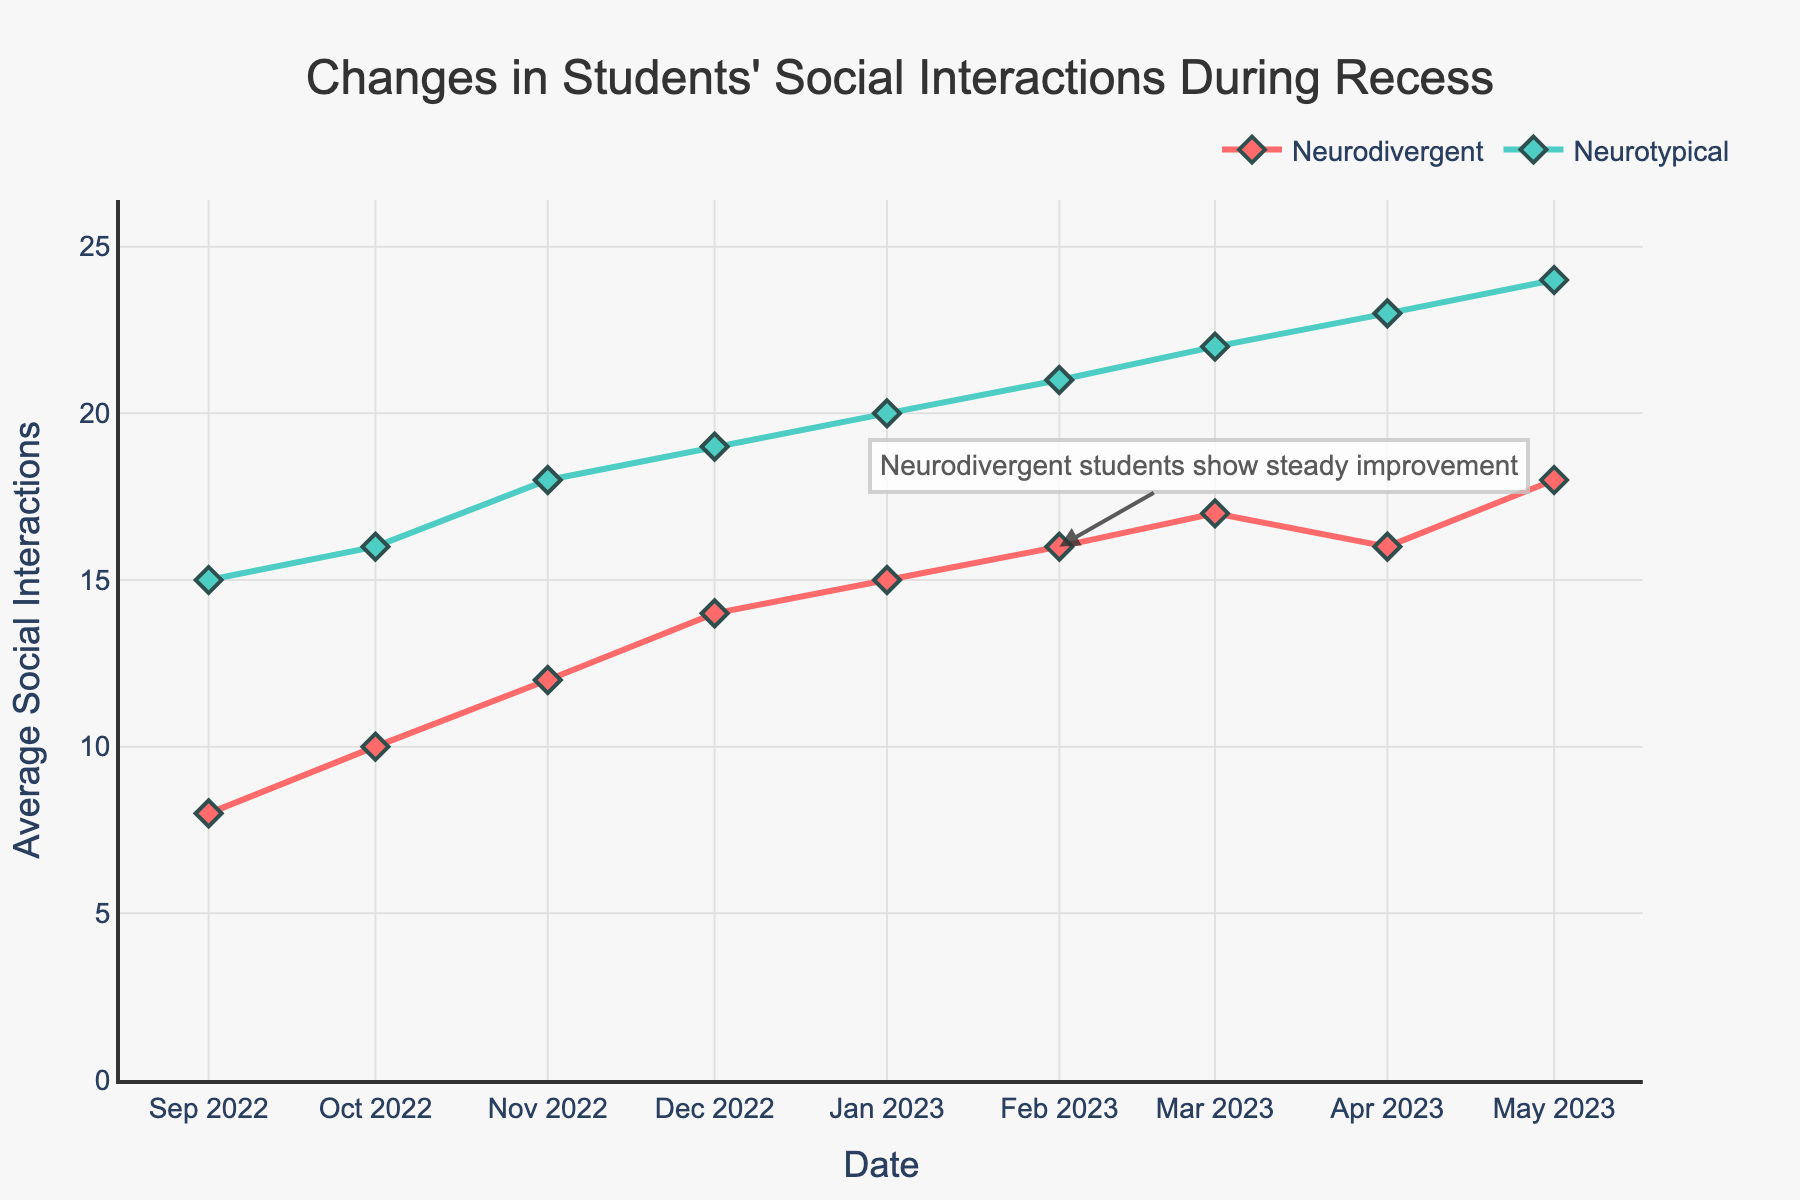What's the title of the plot? The title of the plot is located at the top center and usually described the main subject or insight of the graph.
Answer: Changes in Students' Social Interactions During Recess How many total data points are there in the figure? Count the data points by looking for the markers (diamond shapes) on the lines for both groups in the plot. Each marker represents a data point.
Answer: 16 Which student group shows a steady improvement according to the annotation? Look at the annotation text on the plot, which typically points out key insights directly. The annotation is near "2023-02-01" and mentions the group explicitly.
Answer: Neurodivergent students What trend can you observe for neurodivergent students' social interactions from September 2022 to May 2023? Track the line representing neurodivergent students from the start to the end of the timeline to see how it changes over time.
Answer: Steady increase Which student group had more social interactions during recess in most months? Compare the lines for both groups across most of the timeline and see which line is higher.
Answer: Neurotypical students What was the largest number of social interactions recorded, and for which group and month? Find the highest data point on the plot and identify its corresponding group and date.
Answer: 24, Neurotypical, May 2023 Between which two consecutive months did neurodivergent students have the highest increase in social interactions? Identify the months by observing the biggest vertical jump between two consecutive points for neurodivergent students.
Answer: January to February Did either group experience a decrease in social interactions, and if so, when? Look for any downward trends in the lines for either group and identify the months where such declines happen.
Answer: Neurodivergent, March to April What is the color used for neurotypical students in the plot? Identify the specific color used for the line and markers representing neurotypical students.
Answer: Teal 